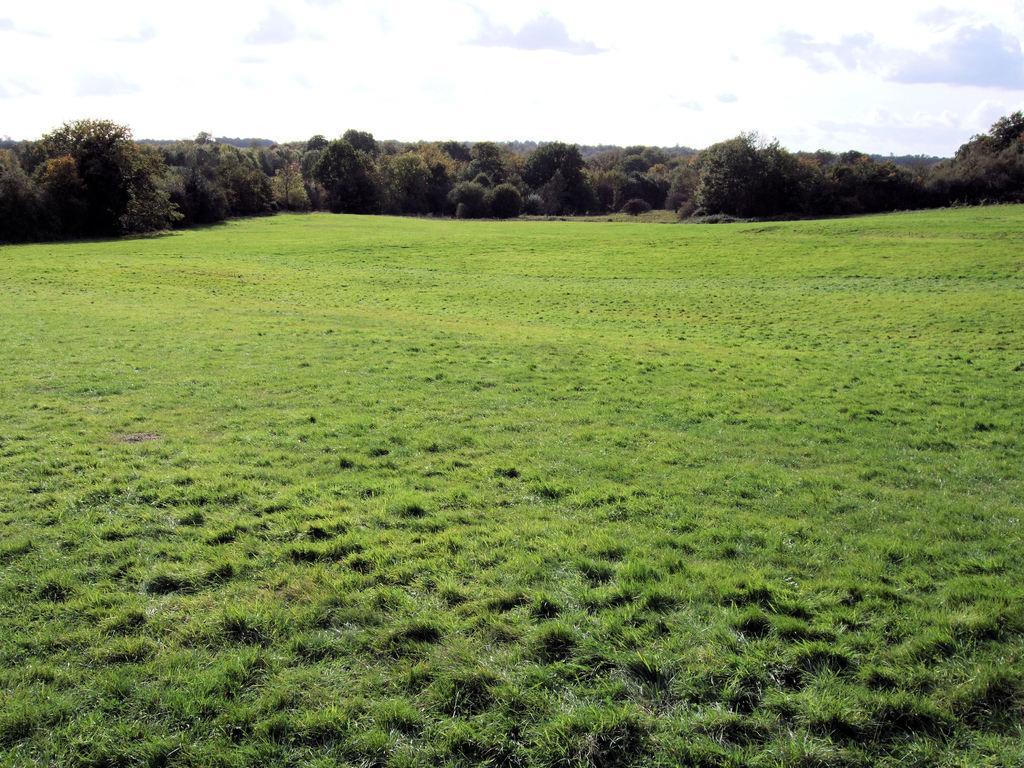How would you summarize this image in a sentence or two? In this picture there is greenery around the area of the image and there is sky at the top side of the image. 